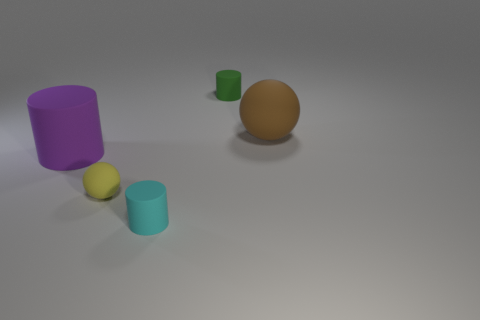Add 3 large rubber objects. How many objects exist? 8 Subtract all balls. How many objects are left? 3 Add 1 green objects. How many green objects exist? 2 Subtract 0 red balls. How many objects are left? 5 Subtract all green matte things. Subtract all big matte cylinders. How many objects are left? 3 Add 3 matte cylinders. How many matte cylinders are left? 6 